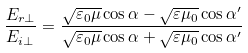Convert formula to latex. <formula><loc_0><loc_0><loc_500><loc_500>\frac { E _ { r \perp } } { E _ { i \perp } } = \frac { \sqrt { \varepsilon _ { 0 } \mu } \cos \alpha - \sqrt { \varepsilon \mu _ { 0 } } \cos \alpha ^ { \prime } } { \sqrt { \varepsilon _ { 0 } \mu } \cos \alpha + \sqrt { \varepsilon \mu _ { 0 } } \cos \alpha ^ { \prime } }</formula> 